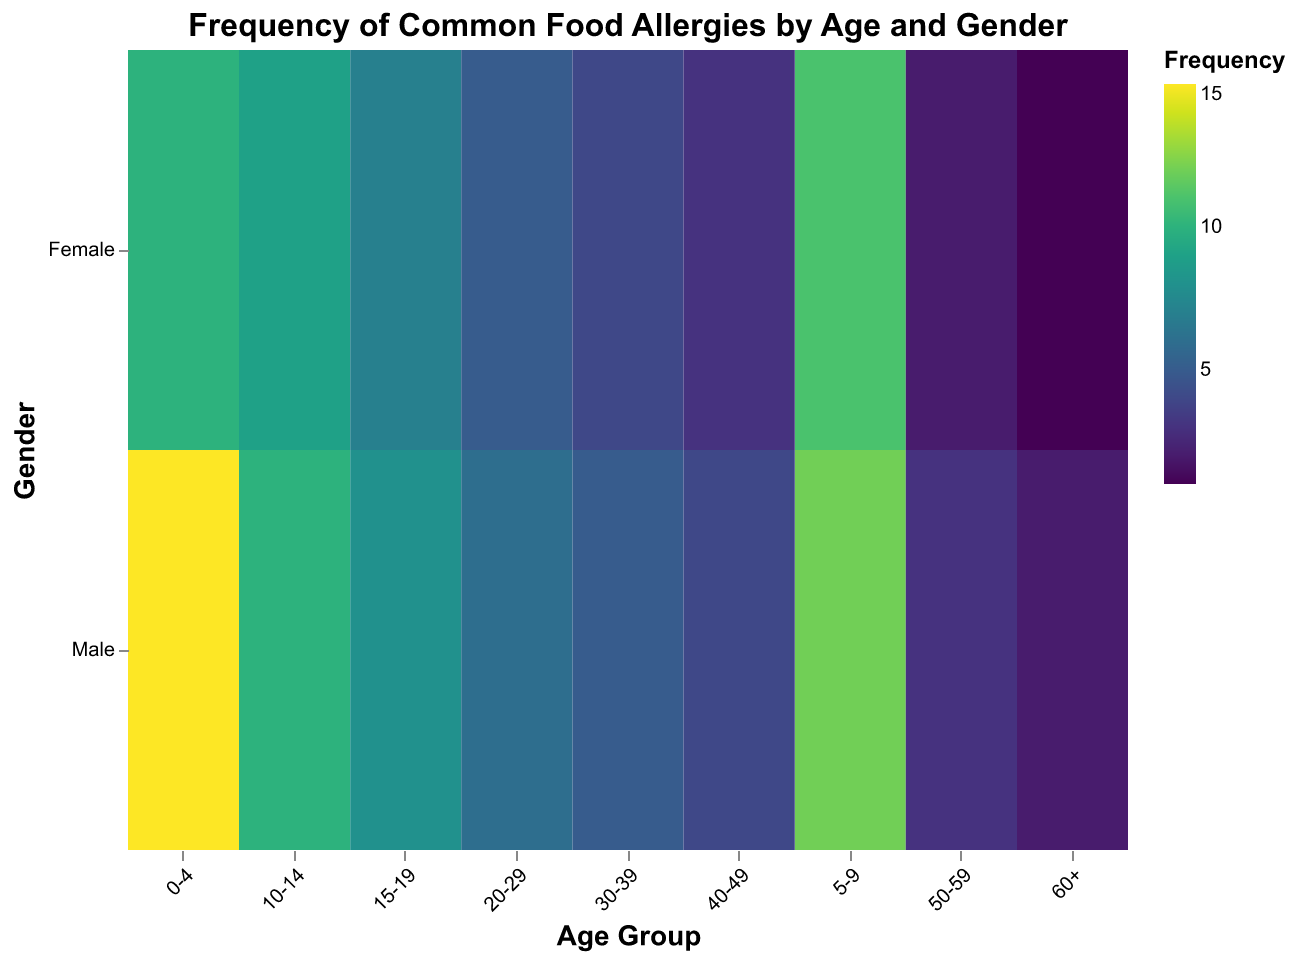What is the title of the heatmap? The title is positioned at the top of the heatmap and provides a brief description of the data being visualized.
Answer: Frequency of Common Food Allergies by Age and Gender Which gender has a higher frequency of Peanut Allergy in the 0-4 age group? Look at the "0-4" age group on the x-axis and compare the colors in the "Male" and "Female" rows. The color indicating a higher frequency will be more intense.
Answer: Male In which age group do males show the highest frequency of Shellfish Allergy? Look for the age group in the "Male" row with the most intense color under the "Shellfish Allergy" category.
Answer: 20-29 How does the frequency of Milk Allergy compare between males and females in the 5-9 age group? Compare the color intensity for "5-9" in both "Male" and "Female" rows under the "Milk Allergy" category.
Answer: Female has a slightly higher frequency Which age group has the lowest frequency of Egg Allergy in females? Find the age group in the "Female" row with the least intense color for "Egg Allergy."
Answer: 50-59 What is the difference in the frequency of Milk Allergy between males aged 10-14 and males aged 50-59? Subtract the frequency of Milk Allergy in males aged 50-59 from that in males aged 10-14.
Answer: 11 Which gender in the 20-29 age group has a lower frequency of Fin Fish Allergy? In the "20-29" age group compare the color intensity between "Male" and "Female" in the "Fin Fish Allergy" category.
Answer: Female Is the frequency of being Allergic to Multiple Foods higher in males or females in the 30-39 age group? Compare the color intensity for "30-39" in both "Male" and "Female" rows under the "Allergic to Multiple Foods" category.
Answer: Female Among the age groups, which one shows the highest frequency of Soy Allergy for males? Identify the age group in the "Male" row with the most intense color for "Soy Allergy."
Answer: 0-4 